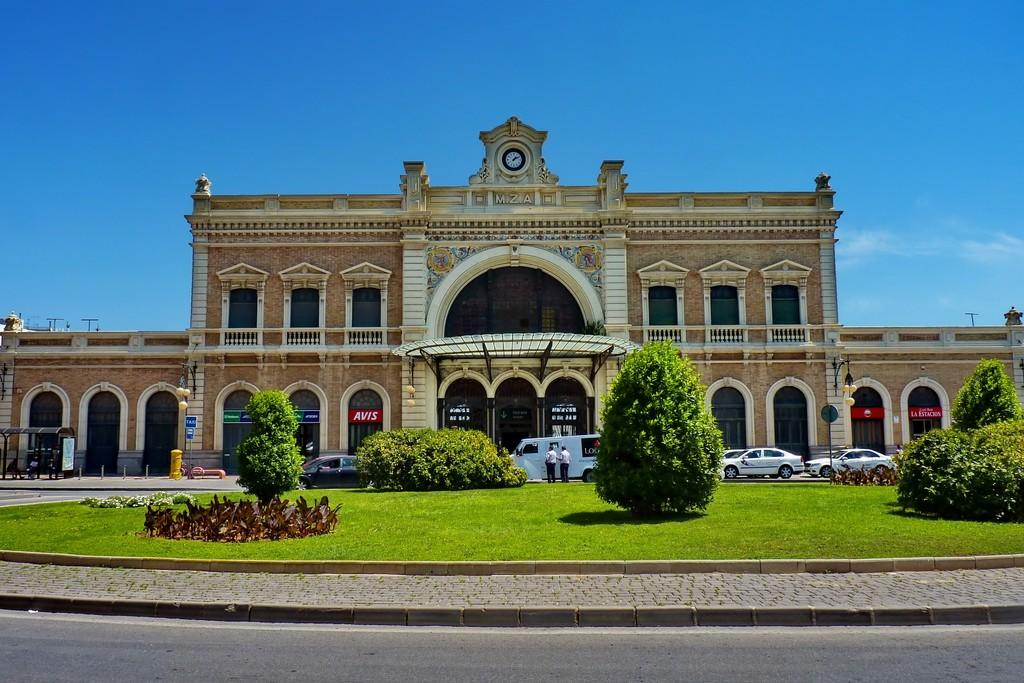<image>
Write a terse but informative summary of the picture. Below the clock on the building, the letters MZA appear. 